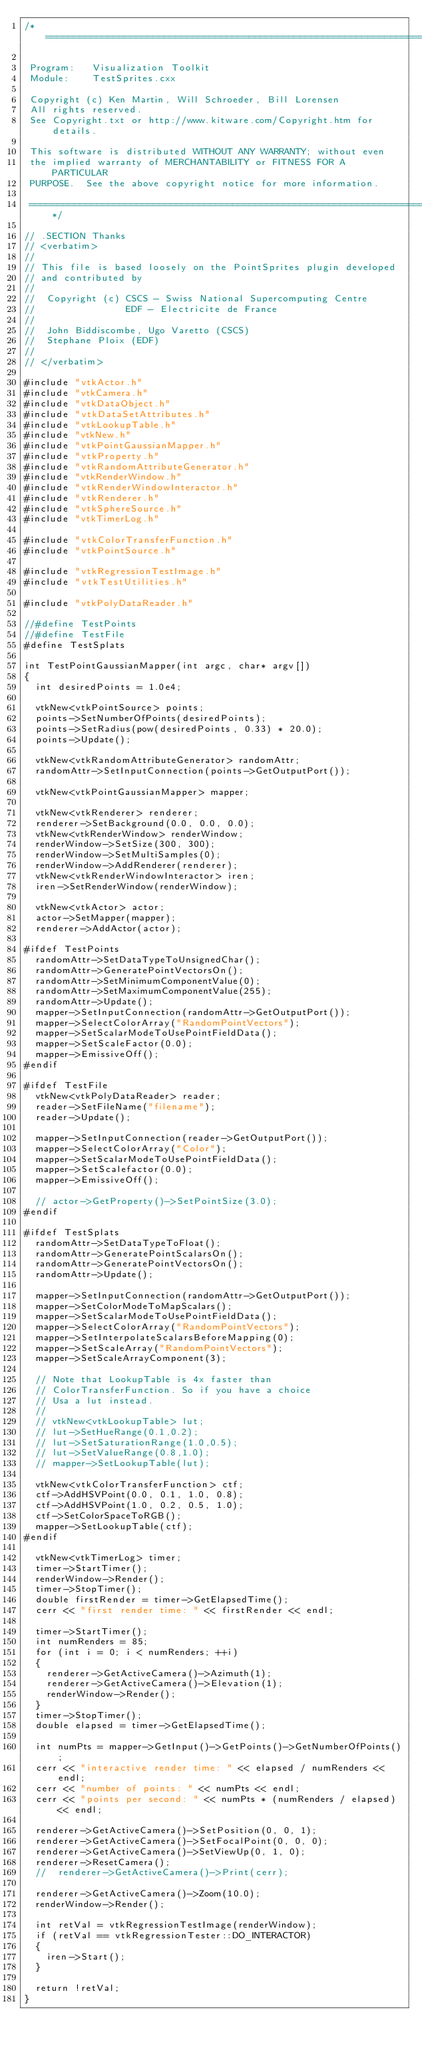Convert code to text. <code><loc_0><loc_0><loc_500><loc_500><_C++_>/*=========================================================================

 Program:   Visualization Toolkit
 Module:    TestSprites.cxx

 Copyright (c) Ken Martin, Will Schroeder, Bill Lorensen
 All rights reserved.
 See Copyright.txt or http://www.kitware.com/Copyright.htm for details.

 This software is distributed WITHOUT ANY WARRANTY; without even
 the implied warranty of MERCHANTABILITY or FITNESS FOR A PARTICULAR
 PURPOSE.  See the above copyright notice for more information.

 =========================================================================*/

// .SECTION Thanks
// <verbatim>
//
// This file is based loosely on the PointSprites plugin developed
// and contributed by
//
//  Copyright (c) CSCS - Swiss National Supercomputing Centre
//                EDF - Electricite de France
//
//  John Biddiscombe, Ugo Varetto (CSCS)
//  Stephane Ploix (EDF)
//
// </verbatim>

#include "vtkActor.h"
#include "vtkCamera.h"
#include "vtkDataObject.h"
#include "vtkDataSetAttributes.h"
#include "vtkLookupTable.h"
#include "vtkNew.h"
#include "vtkPointGaussianMapper.h"
#include "vtkProperty.h"
#include "vtkRandomAttributeGenerator.h"
#include "vtkRenderWindow.h"
#include "vtkRenderWindowInteractor.h"
#include "vtkRenderer.h"
#include "vtkSphereSource.h"
#include "vtkTimerLog.h"

#include "vtkColorTransferFunction.h"
#include "vtkPointSource.h"

#include "vtkRegressionTestImage.h"
#include "vtkTestUtilities.h"

#include "vtkPolyDataReader.h"

//#define TestPoints
//#define TestFile
#define TestSplats

int TestPointGaussianMapper(int argc, char* argv[])
{
  int desiredPoints = 1.0e4;

  vtkNew<vtkPointSource> points;
  points->SetNumberOfPoints(desiredPoints);
  points->SetRadius(pow(desiredPoints, 0.33) * 20.0);
  points->Update();

  vtkNew<vtkRandomAttributeGenerator> randomAttr;
  randomAttr->SetInputConnection(points->GetOutputPort());

  vtkNew<vtkPointGaussianMapper> mapper;

  vtkNew<vtkRenderer> renderer;
  renderer->SetBackground(0.0, 0.0, 0.0);
  vtkNew<vtkRenderWindow> renderWindow;
  renderWindow->SetSize(300, 300);
  renderWindow->SetMultiSamples(0);
  renderWindow->AddRenderer(renderer);
  vtkNew<vtkRenderWindowInteractor> iren;
  iren->SetRenderWindow(renderWindow);

  vtkNew<vtkActor> actor;
  actor->SetMapper(mapper);
  renderer->AddActor(actor);

#ifdef TestPoints
  randomAttr->SetDataTypeToUnsignedChar();
  randomAttr->GeneratePointVectorsOn();
  randomAttr->SetMinimumComponentValue(0);
  randomAttr->SetMaximumComponentValue(255);
  randomAttr->Update();
  mapper->SetInputConnection(randomAttr->GetOutputPort());
  mapper->SelectColorArray("RandomPointVectors");
  mapper->SetScalarModeToUsePointFieldData();
  mapper->SetScaleFactor(0.0);
  mapper->EmissiveOff();
#endif

#ifdef TestFile
  vtkNew<vtkPolyDataReader> reader;
  reader->SetFileName("filename");
  reader->Update();

  mapper->SetInputConnection(reader->GetOutputPort());
  mapper->SelectColorArray("Color");
  mapper->SetScalarModeToUsePointFieldData();
  mapper->SetScalefactor(0.0);
  mapper->EmissiveOff();

  // actor->GetProperty()->SetPointSize(3.0);
#endif

#ifdef TestSplats
  randomAttr->SetDataTypeToFloat();
  randomAttr->GeneratePointScalarsOn();
  randomAttr->GeneratePointVectorsOn();
  randomAttr->Update();

  mapper->SetInputConnection(randomAttr->GetOutputPort());
  mapper->SetColorModeToMapScalars();
  mapper->SetScalarModeToUsePointFieldData();
  mapper->SelectColorArray("RandomPointVectors");
  mapper->SetInterpolateScalarsBeforeMapping(0);
  mapper->SetScaleArray("RandomPointVectors");
  mapper->SetScaleArrayComponent(3);

  // Note that LookupTable is 4x faster than
  // ColorTransferFunction. So if you have a choice
  // Usa a lut instead.
  //
  // vtkNew<vtkLookupTable> lut;
  // lut->SetHueRange(0.1,0.2);
  // lut->SetSaturationRange(1.0,0.5);
  // lut->SetValueRange(0.8,1.0);
  // mapper->SetLookupTable(lut);

  vtkNew<vtkColorTransferFunction> ctf;
  ctf->AddHSVPoint(0.0, 0.1, 1.0, 0.8);
  ctf->AddHSVPoint(1.0, 0.2, 0.5, 1.0);
  ctf->SetColorSpaceToRGB();
  mapper->SetLookupTable(ctf);
#endif

  vtkNew<vtkTimerLog> timer;
  timer->StartTimer();
  renderWindow->Render();
  timer->StopTimer();
  double firstRender = timer->GetElapsedTime();
  cerr << "first render time: " << firstRender << endl;

  timer->StartTimer();
  int numRenders = 85;
  for (int i = 0; i < numRenders; ++i)
  {
    renderer->GetActiveCamera()->Azimuth(1);
    renderer->GetActiveCamera()->Elevation(1);
    renderWindow->Render();
  }
  timer->StopTimer();
  double elapsed = timer->GetElapsedTime();

  int numPts = mapper->GetInput()->GetPoints()->GetNumberOfPoints();
  cerr << "interactive render time: " << elapsed / numRenders << endl;
  cerr << "number of points: " << numPts << endl;
  cerr << "points per second: " << numPts * (numRenders / elapsed) << endl;

  renderer->GetActiveCamera()->SetPosition(0, 0, 1);
  renderer->GetActiveCamera()->SetFocalPoint(0, 0, 0);
  renderer->GetActiveCamera()->SetViewUp(0, 1, 0);
  renderer->ResetCamera();
  //  renderer->GetActiveCamera()->Print(cerr);

  renderer->GetActiveCamera()->Zoom(10.0);
  renderWindow->Render();

  int retVal = vtkRegressionTestImage(renderWindow);
  if (retVal == vtkRegressionTester::DO_INTERACTOR)
  {
    iren->Start();
  }

  return !retVal;
}
</code> 